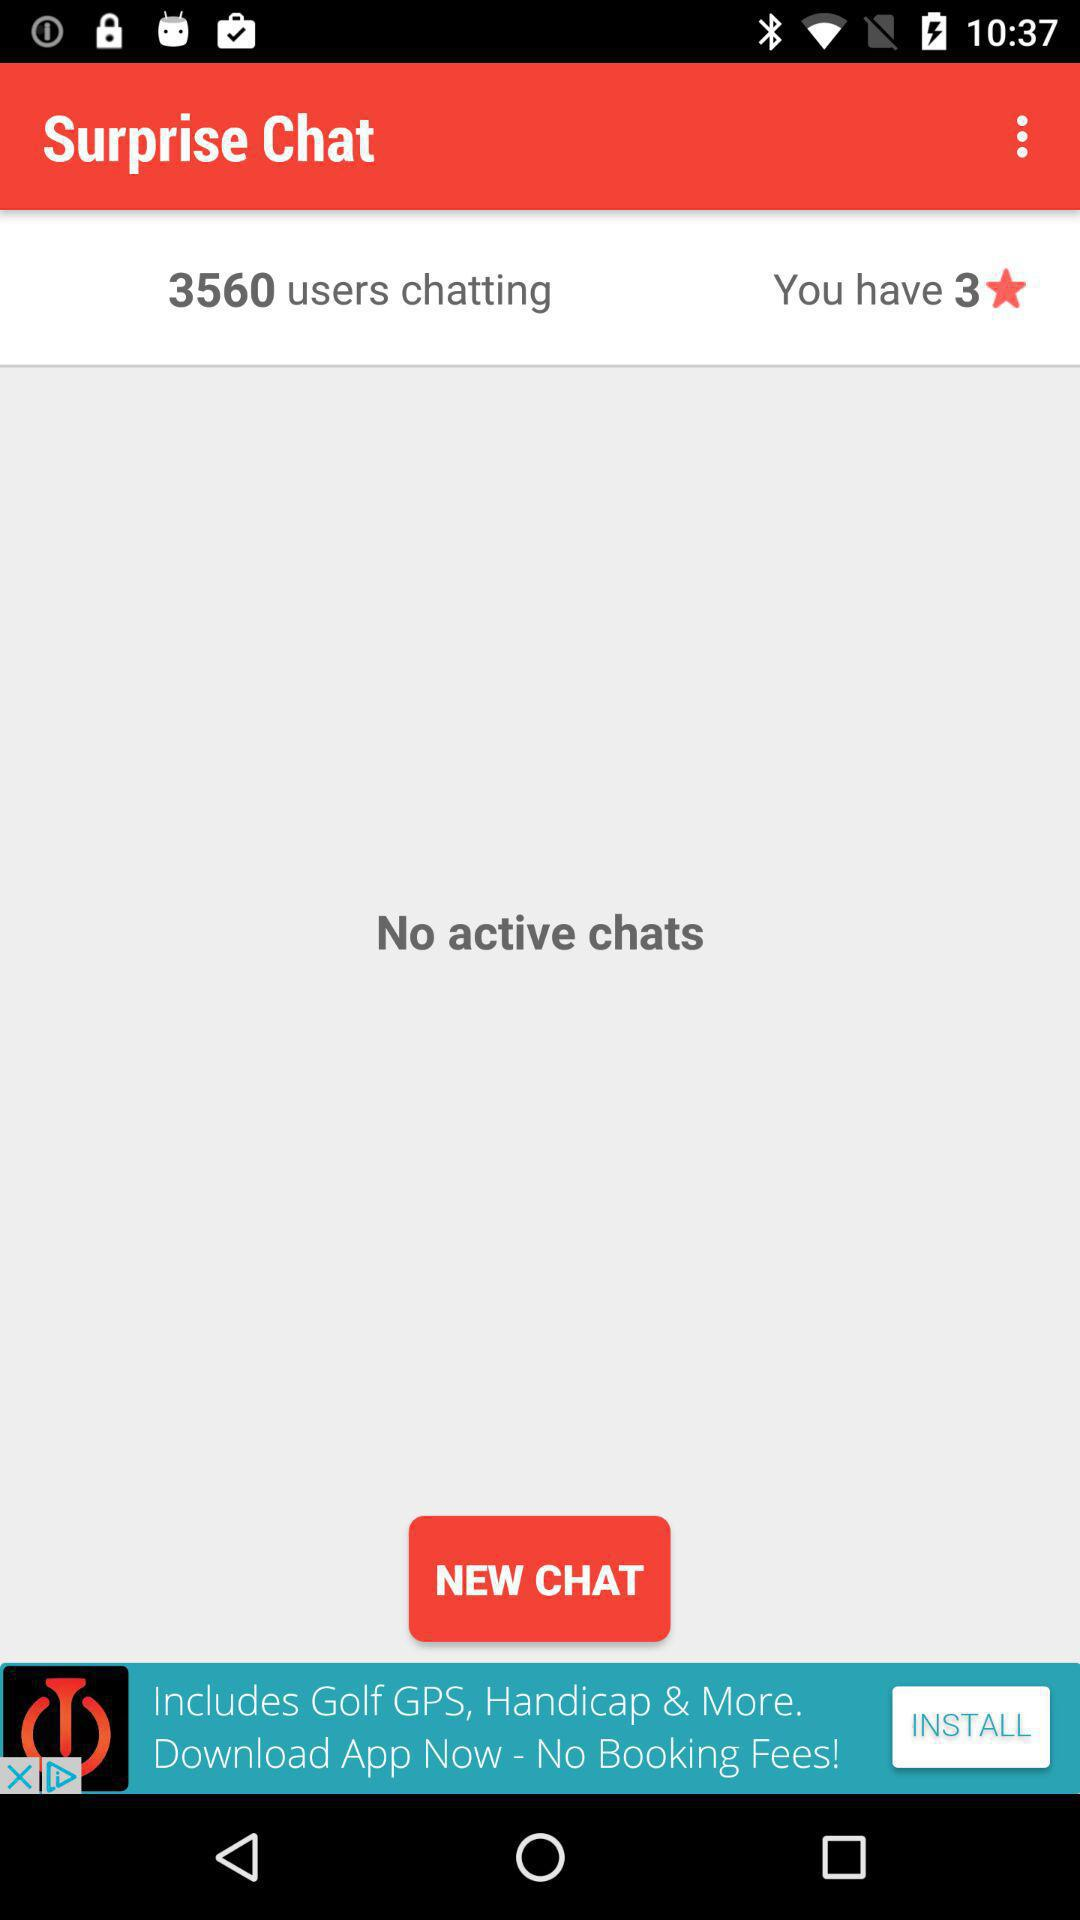How many users are chatting? There are 3560 users chatting. 